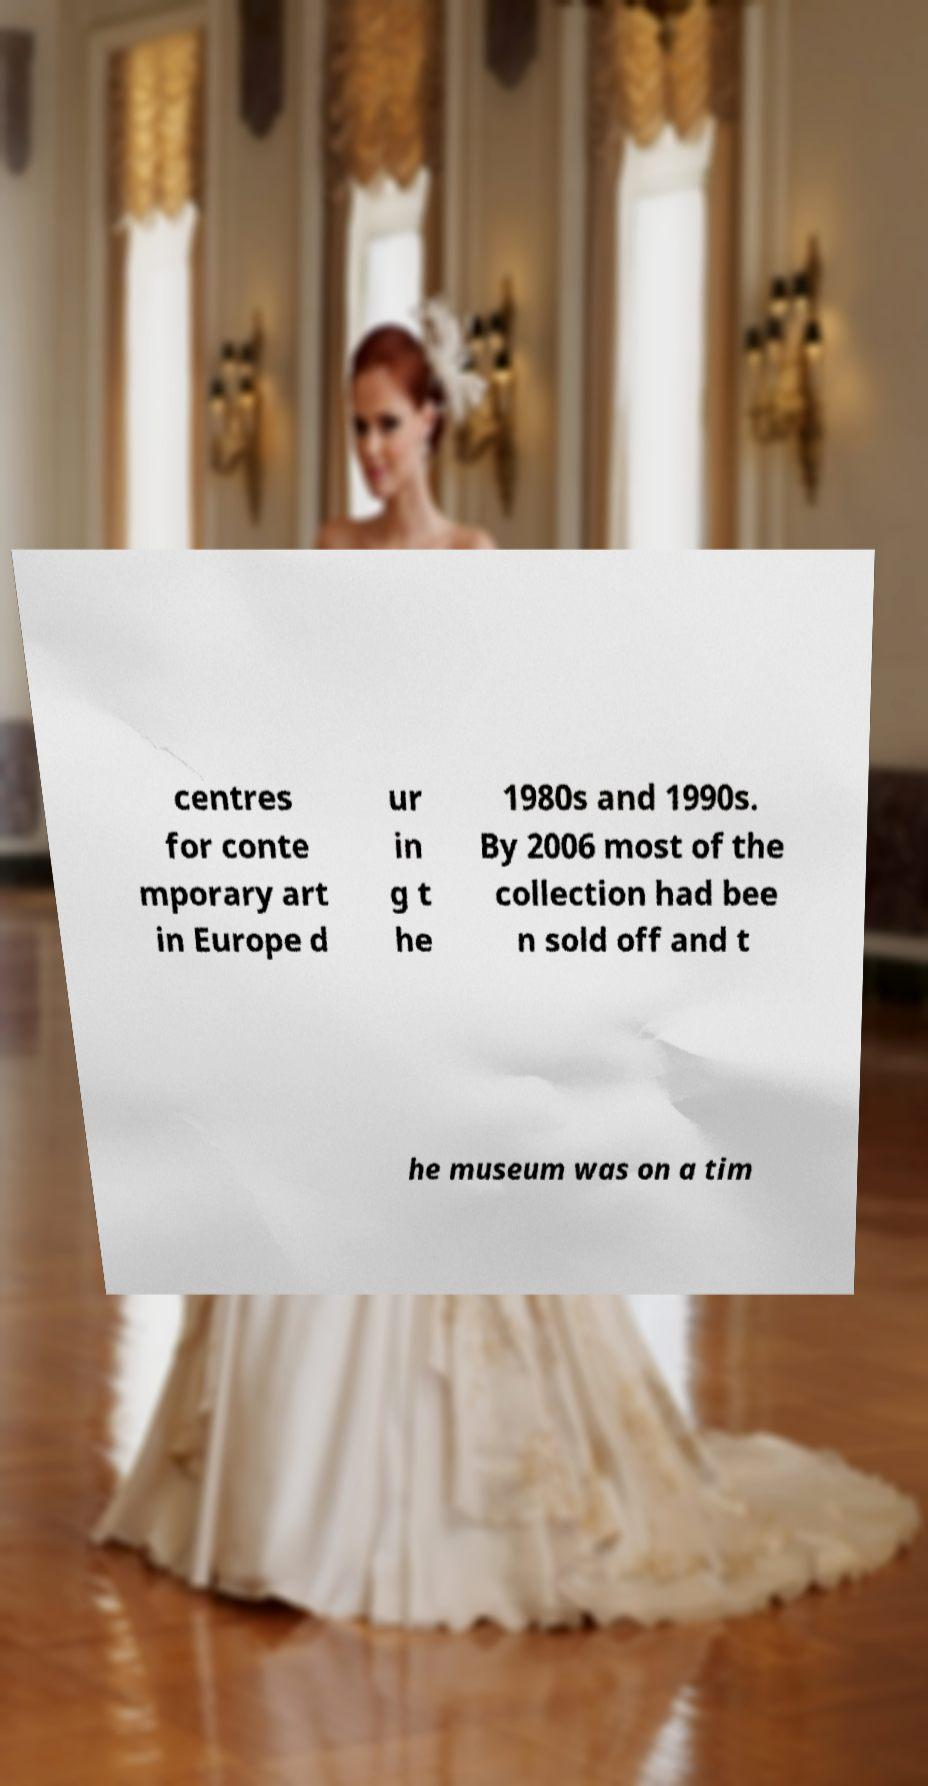Could you assist in decoding the text presented in this image and type it out clearly? centres for conte mporary art in Europe d ur in g t he 1980s and 1990s. By 2006 most of the collection had bee n sold off and t he museum was on a tim 